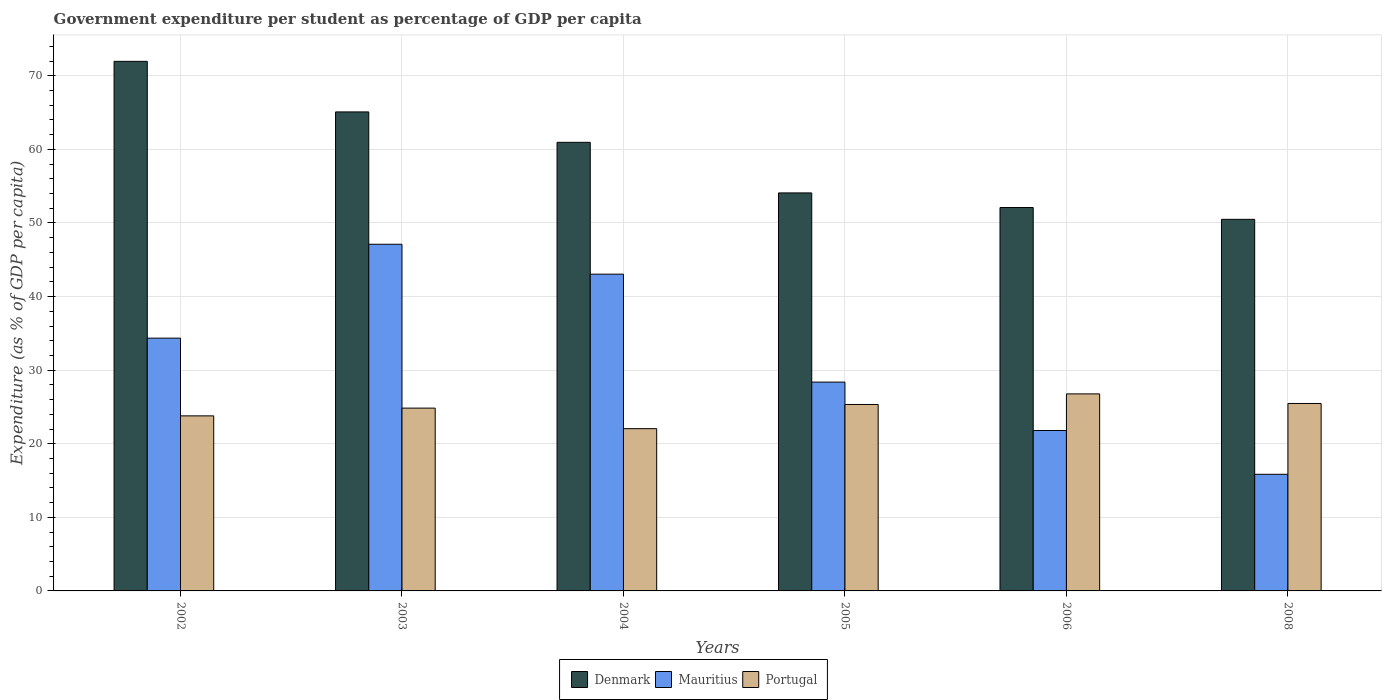How many groups of bars are there?
Offer a terse response. 6. Are the number of bars on each tick of the X-axis equal?
Ensure brevity in your answer.  Yes. In how many cases, is the number of bars for a given year not equal to the number of legend labels?
Provide a succinct answer. 0. What is the percentage of expenditure per student in Mauritius in 2005?
Your answer should be compact. 28.38. Across all years, what is the maximum percentage of expenditure per student in Mauritius?
Give a very brief answer. 47.11. Across all years, what is the minimum percentage of expenditure per student in Portugal?
Offer a terse response. 22.05. In which year was the percentage of expenditure per student in Denmark maximum?
Your answer should be very brief. 2002. In which year was the percentage of expenditure per student in Denmark minimum?
Make the answer very short. 2008. What is the total percentage of expenditure per student in Mauritius in the graph?
Offer a very short reply. 190.53. What is the difference between the percentage of expenditure per student in Denmark in 2002 and that in 2006?
Offer a very short reply. 19.86. What is the difference between the percentage of expenditure per student in Denmark in 2008 and the percentage of expenditure per student in Mauritius in 2003?
Ensure brevity in your answer.  3.39. What is the average percentage of expenditure per student in Denmark per year?
Give a very brief answer. 59.12. In the year 2008, what is the difference between the percentage of expenditure per student in Denmark and percentage of expenditure per student in Mauritius?
Keep it short and to the point. 34.65. What is the ratio of the percentage of expenditure per student in Portugal in 2003 to that in 2004?
Your response must be concise. 1.13. Is the percentage of expenditure per student in Denmark in 2003 less than that in 2004?
Provide a short and direct response. No. Is the difference between the percentage of expenditure per student in Denmark in 2003 and 2004 greater than the difference between the percentage of expenditure per student in Mauritius in 2003 and 2004?
Provide a short and direct response. Yes. What is the difference between the highest and the second highest percentage of expenditure per student in Portugal?
Give a very brief answer. 1.3. What is the difference between the highest and the lowest percentage of expenditure per student in Portugal?
Your response must be concise. 4.73. In how many years, is the percentage of expenditure per student in Denmark greater than the average percentage of expenditure per student in Denmark taken over all years?
Give a very brief answer. 3. Is the sum of the percentage of expenditure per student in Portugal in 2003 and 2008 greater than the maximum percentage of expenditure per student in Mauritius across all years?
Your answer should be compact. Yes. What does the 1st bar from the left in 2006 represents?
Offer a very short reply. Denmark. What does the 2nd bar from the right in 2005 represents?
Your answer should be compact. Mauritius. Are all the bars in the graph horizontal?
Give a very brief answer. No. How many years are there in the graph?
Provide a short and direct response. 6. Where does the legend appear in the graph?
Ensure brevity in your answer.  Bottom center. What is the title of the graph?
Provide a succinct answer. Government expenditure per student as percentage of GDP per capita. What is the label or title of the Y-axis?
Provide a short and direct response. Expenditure (as % of GDP per capita). What is the Expenditure (as % of GDP per capita) of Denmark in 2002?
Give a very brief answer. 71.97. What is the Expenditure (as % of GDP per capita) in Mauritius in 2002?
Your response must be concise. 34.35. What is the Expenditure (as % of GDP per capita) of Portugal in 2002?
Provide a succinct answer. 23.79. What is the Expenditure (as % of GDP per capita) in Denmark in 2003?
Your answer should be compact. 65.09. What is the Expenditure (as % of GDP per capita) of Mauritius in 2003?
Provide a short and direct response. 47.11. What is the Expenditure (as % of GDP per capita) in Portugal in 2003?
Offer a terse response. 24.84. What is the Expenditure (as % of GDP per capita) of Denmark in 2004?
Your answer should be very brief. 60.96. What is the Expenditure (as % of GDP per capita) in Mauritius in 2004?
Offer a very short reply. 43.05. What is the Expenditure (as % of GDP per capita) of Portugal in 2004?
Your answer should be compact. 22.05. What is the Expenditure (as % of GDP per capita) of Denmark in 2005?
Offer a terse response. 54.09. What is the Expenditure (as % of GDP per capita) in Mauritius in 2005?
Your response must be concise. 28.38. What is the Expenditure (as % of GDP per capita) of Portugal in 2005?
Provide a short and direct response. 25.34. What is the Expenditure (as % of GDP per capita) in Denmark in 2006?
Offer a very short reply. 52.1. What is the Expenditure (as % of GDP per capita) of Mauritius in 2006?
Your response must be concise. 21.8. What is the Expenditure (as % of GDP per capita) of Portugal in 2006?
Make the answer very short. 26.78. What is the Expenditure (as % of GDP per capita) of Denmark in 2008?
Your response must be concise. 50.5. What is the Expenditure (as % of GDP per capita) of Mauritius in 2008?
Your response must be concise. 15.85. What is the Expenditure (as % of GDP per capita) of Portugal in 2008?
Make the answer very short. 25.47. Across all years, what is the maximum Expenditure (as % of GDP per capita) of Denmark?
Your answer should be very brief. 71.97. Across all years, what is the maximum Expenditure (as % of GDP per capita) in Mauritius?
Your answer should be very brief. 47.11. Across all years, what is the maximum Expenditure (as % of GDP per capita) of Portugal?
Your response must be concise. 26.78. Across all years, what is the minimum Expenditure (as % of GDP per capita) of Denmark?
Your answer should be compact. 50.5. Across all years, what is the minimum Expenditure (as % of GDP per capita) of Mauritius?
Give a very brief answer. 15.85. Across all years, what is the minimum Expenditure (as % of GDP per capita) of Portugal?
Provide a succinct answer. 22.05. What is the total Expenditure (as % of GDP per capita) of Denmark in the graph?
Provide a succinct answer. 354.71. What is the total Expenditure (as % of GDP per capita) of Mauritius in the graph?
Ensure brevity in your answer.  190.53. What is the total Expenditure (as % of GDP per capita) of Portugal in the graph?
Make the answer very short. 148.27. What is the difference between the Expenditure (as % of GDP per capita) in Denmark in 2002 and that in 2003?
Your answer should be very brief. 6.87. What is the difference between the Expenditure (as % of GDP per capita) in Mauritius in 2002 and that in 2003?
Ensure brevity in your answer.  -12.76. What is the difference between the Expenditure (as % of GDP per capita) of Portugal in 2002 and that in 2003?
Provide a short and direct response. -1.05. What is the difference between the Expenditure (as % of GDP per capita) in Denmark in 2002 and that in 2004?
Your answer should be compact. 11. What is the difference between the Expenditure (as % of GDP per capita) of Mauritius in 2002 and that in 2004?
Your response must be concise. -8.7. What is the difference between the Expenditure (as % of GDP per capita) in Portugal in 2002 and that in 2004?
Make the answer very short. 1.74. What is the difference between the Expenditure (as % of GDP per capita) of Denmark in 2002 and that in 2005?
Ensure brevity in your answer.  17.88. What is the difference between the Expenditure (as % of GDP per capita) of Mauritius in 2002 and that in 2005?
Ensure brevity in your answer.  5.97. What is the difference between the Expenditure (as % of GDP per capita) of Portugal in 2002 and that in 2005?
Your answer should be very brief. -1.55. What is the difference between the Expenditure (as % of GDP per capita) of Denmark in 2002 and that in 2006?
Your answer should be compact. 19.86. What is the difference between the Expenditure (as % of GDP per capita) of Mauritius in 2002 and that in 2006?
Your answer should be very brief. 12.55. What is the difference between the Expenditure (as % of GDP per capita) in Portugal in 2002 and that in 2006?
Provide a short and direct response. -2.99. What is the difference between the Expenditure (as % of GDP per capita) in Denmark in 2002 and that in 2008?
Give a very brief answer. 21.47. What is the difference between the Expenditure (as % of GDP per capita) in Mauritius in 2002 and that in 2008?
Your answer should be very brief. 18.5. What is the difference between the Expenditure (as % of GDP per capita) of Portugal in 2002 and that in 2008?
Provide a short and direct response. -1.68. What is the difference between the Expenditure (as % of GDP per capita) of Denmark in 2003 and that in 2004?
Make the answer very short. 4.13. What is the difference between the Expenditure (as % of GDP per capita) of Mauritius in 2003 and that in 2004?
Keep it short and to the point. 4.06. What is the difference between the Expenditure (as % of GDP per capita) of Portugal in 2003 and that in 2004?
Keep it short and to the point. 2.79. What is the difference between the Expenditure (as % of GDP per capita) of Denmark in 2003 and that in 2005?
Provide a short and direct response. 11.01. What is the difference between the Expenditure (as % of GDP per capita) of Mauritius in 2003 and that in 2005?
Offer a very short reply. 18.73. What is the difference between the Expenditure (as % of GDP per capita) in Portugal in 2003 and that in 2005?
Offer a terse response. -0.49. What is the difference between the Expenditure (as % of GDP per capita) of Denmark in 2003 and that in 2006?
Give a very brief answer. 12.99. What is the difference between the Expenditure (as % of GDP per capita) of Mauritius in 2003 and that in 2006?
Your response must be concise. 25.31. What is the difference between the Expenditure (as % of GDP per capita) in Portugal in 2003 and that in 2006?
Your answer should be very brief. -1.93. What is the difference between the Expenditure (as % of GDP per capita) in Denmark in 2003 and that in 2008?
Your answer should be very brief. 14.6. What is the difference between the Expenditure (as % of GDP per capita) of Mauritius in 2003 and that in 2008?
Offer a very short reply. 31.26. What is the difference between the Expenditure (as % of GDP per capita) in Portugal in 2003 and that in 2008?
Provide a short and direct response. -0.63. What is the difference between the Expenditure (as % of GDP per capita) in Denmark in 2004 and that in 2005?
Your answer should be very brief. 6.87. What is the difference between the Expenditure (as % of GDP per capita) in Mauritius in 2004 and that in 2005?
Provide a succinct answer. 14.67. What is the difference between the Expenditure (as % of GDP per capita) in Portugal in 2004 and that in 2005?
Your response must be concise. -3.29. What is the difference between the Expenditure (as % of GDP per capita) in Denmark in 2004 and that in 2006?
Keep it short and to the point. 8.86. What is the difference between the Expenditure (as % of GDP per capita) of Mauritius in 2004 and that in 2006?
Give a very brief answer. 21.25. What is the difference between the Expenditure (as % of GDP per capita) in Portugal in 2004 and that in 2006?
Your answer should be very brief. -4.73. What is the difference between the Expenditure (as % of GDP per capita) of Denmark in 2004 and that in 2008?
Offer a very short reply. 10.46. What is the difference between the Expenditure (as % of GDP per capita) in Mauritius in 2004 and that in 2008?
Your response must be concise. 27.2. What is the difference between the Expenditure (as % of GDP per capita) in Portugal in 2004 and that in 2008?
Keep it short and to the point. -3.42. What is the difference between the Expenditure (as % of GDP per capita) in Denmark in 2005 and that in 2006?
Offer a terse response. 1.99. What is the difference between the Expenditure (as % of GDP per capita) in Mauritius in 2005 and that in 2006?
Offer a terse response. 6.58. What is the difference between the Expenditure (as % of GDP per capita) in Portugal in 2005 and that in 2006?
Your response must be concise. -1.44. What is the difference between the Expenditure (as % of GDP per capita) of Denmark in 2005 and that in 2008?
Make the answer very short. 3.59. What is the difference between the Expenditure (as % of GDP per capita) of Mauritius in 2005 and that in 2008?
Provide a short and direct response. 12.53. What is the difference between the Expenditure (as % of GDP per capita) of Portugal in 2005 and that in 2008?
Give a very brief answer. -0.14. What is the difference between the Expenditure (as % of GDP per capita) of Denmark in 2006 and that in 2008?
Your response must be concise. 1.61. What is the difference between the Expenditure (as % of GDP per capita) of Mauritius in 2006 and that in 2008?
Offer a very short reply. 5.95. What is the difference between the Expenditure (as % of GDP per capita) in Portugal in 2006 and that in 2008?
Provide a short and direct response. 1.3. What is the difference between the Expenditure (as % of GDP per capita) in Denmark in 2002 and the Expenditure (as % of GDP per capita) in Mauritius in 2003?
Offer a terse response. 24.86. What is the difference between the Expenditure (as % of GDP per capita) of Denmark in 2002 and the Expenditure (as % of GDP per capita) of Portugal in 2003?
Provide a succinct answer. 47.12. What is the difference between the Expenditure (as % of GDP per capita) of Mauritius in 2002 and the Expenditure (as % of GDP per capita) of Portugal in 2003?
Make the answer very short. 9.51. What is the difference between the Expenditure (as % of GDP per capita) of Denmark in 2002 and the Expenditure (as % of GDP per capita) of Mauritius in 2004?
Provide a succinct answer. 28.92. What is the difference between the Expenditure (as % of GDP per capita) in Denmark in 2002 and the Expenditure (as % of GDP per capita) in Portugal in 2004?
Offer a very short reply. 49.92. What is the difference between the Expenditure (as % of GDP per capita) in Mauritius in 2002 and the Expenditure (as % of GDP per capita) in Portugal in 2004?
Provide a short and direct response. 12.3. What is the difference between the Expenditure (as % of GDP per capita) in Denmark in 2002 and the Expenditure (as % of GDP per capita) in Mauritius in 2005?
Provide a succinct answer. 43.59. What is the difference between the Expenditure (as % of GDP per capita) of Denmark in 2002 and the Expenditure (as % of GDP per capita) of Portugal in 2005?
Give a very brief answer. 46.63. What is the difference between the Expenditure (as % of GDP per capita) in Mauritius in 2002 and the Expenditure (as % of GDP per capita) in Portugal in 2005?
Make the answer very short. 9.01. What is the difference between the Expenditure (as % of GDP per capita) in Denmark in 2002 and the Expenditure (as % of GDP per capita) in Mauritius in 2006?
Make the answer very short. 50.17. What is the difference between the Expenditure (as % of GDP per capita) in Denmark in 2002 and the Expenditure (as % of GDP per capita) in Portugal in 2006?
Your response must be concise. 45.19. What is the difference between the Expenditure (as % of GDP per capita) of Mauritius in 2002 and the Expenditure (as % of GDP per capita) of Portugal in 2006?
Offer a very short reply. 7.57. What is the difference between the Expenditure (as % of GDP per capita) in Denmark in 2002 and the Expenditure (as % of GDP per capita) in Mauritius in 2008?
Provide a short and direct response. 56.12. What is the difference between the Expenditure (as % of GDP per capita) of Denmark in 2002 and the Expenditure (as % of GDP per capita) of Portugal in 2008?
Provide a succinct answer. 46.49. What is the difference between the Expenditure (as % of GDP per capita) in Mauritius in 2002 and the Expenditure (as % of GDP per capita) in Portugal in 2008?
Keep it short and to the point. 8.88. What is the difference between the Expenditure (as % of GDP per capita) of Denmark in 2003 and the Expenditure (as % of GDP per capita) of Mauritius in 2004?
Your answer should be compact. 22.05. What is the difference between the Expenditure (as % of GDP per capita) of Denmark in 2003 and the Expenditure (as % of GDP per capita) of Portugal in 2004?
Keep it short and to the point. 43.04. What is the difference between the Expenditure (as % of GDP per capita) of Mauritius in 2003 and the Expenditure (as % of GDP per capita) of Portugal in 2004?
Your answer should be very brief. 25.06. What is the difference between the Expenditure (as % of GDP per capita) in Denmark in 2003 and the Expenditure (as % of GDP per capita) in Mauritius in 2005?
Your response must be concise. 36.72. What is the difference between the Expenditure (as % of GDP per capita) of Denmark in 2003 and the Expenditure (as % of GDP per capita) of Portugal in 2005?
Provide a succinct answer. 39.76. What is the difference between the Expenditure (as % of GDP per capita) in Mauritius in 2003 and the Expenditure (as % of GDP per capita) in Portugal in 2005?
Your answer should be very brief. 21.77. What is the difference between the Expenditure (as % of GDP per capita) of Denmark in 2003 and the Expenditure (as % of GDP per capita) of Mauritius in 2006?
Your answer should be very brief. 43.29. What is the difference between the Expenditure (as % of GDP per capita) in Denmark in 2003 and the Expenditure (as % of GDP per capita) in Portugal in 2006?
Offer a very short reply. 38.32. What is the difference between the Expenditure (as % of GDP per capita) of Mauritius in 2003 and the Expenditure (as % of GDP per capita) of Portugal in 2006?
Ensure brevity in your answer.  20.33. What is the difference between the Expenditure (as % of GDP per capita) in Denmark in 2003 and the Expenditure (as % of GDP per capita) in Mauritius in 2008?
Give a very brief answer. 49.24. What is the difference between the Expenditure (as % of GDP per capita) of Denmark in 2003 and the Expenditure (as % of GDP per capita) of Portugal in 2008?
Your answer should be compact. 39.62. What is the difference between the Expenditure (as % of GDP per capita) of Mauritius in 2003 and the Expenditure (as % of GDP per capita) of Portugal in 2008?
Your response must be concise. 21.64. What is the difference between the Expenditure (as % of GDP per capita) in Denmark in 2004 and the Expenditure (as % of GDP per capita) in Mauritius in 2005?
Your response must be concise. 32.58. What is the difference between the Expenditure (as % of GDP per capita) in Denmark in 2004 and the Expenditure (as % of GDP per capita) in Portugal in 2005?
Offer a very short reply. 35.62. What is the difference between the Expenditure (as % of GDP per capita) of Mauritius in 2004 and the Expenditure (as % of GDP per capita) of Portugal in 2005?
Offer a very short reply. 17.71. What is the difference between the Expenditure (as % of GDP per capita) in Denmark in 2004 and the Expenditure (as % of GDP per capita) in Mauritius in 2006?
Offer a terse response. 39.16. What is the difference between the Expenditure (as % of GDP per capita) of Denmark in 2004 and the Expenditure (as % of GDP per capita) of Portugal in 2006?
Your response must be concise. 34.19. What is the difference between the Expenditure (as % of GDP per capita) in Mauritius in 2004 and the Expenditure (as % of GDP per capita) in Portugal in 2006?
Offer a very short reply. 16.27. What is the difference between the Expenditure (as % of GDP per capita) in Denmark in 2004 and the Expenditure (as % of GDP per capita) in Mauritius in 2008?
Provide a succinct answer. 45.11. What is the difference between the Expenditure (as % of GDP per capita) in Denmark in 2004 and the Expenditure (as % of GDP per capita) in Portugal in 2008?
Offer a terse response. 35.49. What is the difference between the Expenditure (as % of GDP per capita) of Mauritius in 2004 and the Expenditure (as % of GDP per capita) of Portugal in 2008?
Offer a very short reply. 17.57. What is the difference between the Expenditure (as % of GDP per capita) of Denmark in 2005 and the Expenditure (as % of GDP per capita) of Mauritius in 2006?
Keep it short and to the point. 32.29. What is the difference between the Expenditure (as % of GDP per capita) in Denmark in 2005 and the Expenditure (as % of GDP per capita) in Portugal in 2006?
Provide a succinct answer. 27.31. What is the difference between the Expenditure (as % of GDP per capita) in Mauritius in 2005 and the Expenditure (as % of GDP per capita) in Portugal in 2006?
Your response must be concise. 1.6. What is the difference between the Expenditure (as % of GDP per capita) of Denmark in 2005 and the Expenditure (as % of GDP per capita) of Mauritius in 2008?
Provide a succinct answer. 38.24. What is the difference between the Expenditure (as % of GDP per capita) in Denmark in 2005 and the Expenditure (as % of GDP per capita) in Portugal in 2008?
Offer a terse response. 28.61. What is the difference between the Expenditure (as % of GDP per capita) in Mauritius in 2005 and the Expenditure (as % of GDP per capita) in Portugal in 2008?
Your answer should be compact. 2.91. What is the difference between the Expenditure (as % of GDP per capita) in Denmark in 2006 and the Expenditure (as % of GDP per capita) in Mauritius in 2008?
Your answer should be compact. 36.25. What is the difference between the Expenditure (as % of GDP per capita) in Denmark in 2006 and the Expenditure (as % of GDP per capita) in Portugal in 2008?
Your answer should be compact. 26.63. What is the difference between the Expenditure (as % of GDP per capita) of Mauritius in 2006 and the Expenditure (as % of GDP per capita) of Portugal in 2008?
Give a very brief answer. -3.67. What is the average Expenditure (as % of GDP per capita) in Denmark per year?
Keep it short and to the point. 59.12. What is the average Expenditure (as % of GDP per capita) in Mauritius per year?
Your response must be concise. 31.76. What is the average Expenditure (as % of GDP per capita) of Portugal per year?
Your answer should be compact. 24.71. In the year 2002, what is the difference between the Expenditure (as % of GDP per capita) in Denmark and Expenditure (as % of GDP per capita) in Mauritius?
Provide a succinct answer. 37.62. In the year 2002, what is the difference between the Expenditure (as % of GDP per capita) in Denmark and Expenditure (as % of GDP per capita) in Portugal?
Provide a short and direct response. 48.18. In the year 2002, what is the difference between the Expenditure (as % of GDP per capita) of Mauritius and Expenditure (as % of GDP per capita) of Portugal?
Provide a short and direct response. 10.56. In the year 2003, what is the difference between the Expenditure (as % of GDP per capita) of Denmark and Expenditure (as % of GDP per capita) of Mauritius?
Make the answer very short. 17.98. In the year 2003, what is the difference between the Expenditure (as % of GDP per capita) of Denmark and Expenditure (as % of GDP per capita) of Portugal?
Provide a succinct answer. 40.25. In the year 2003, what is the difference between the Expenditure (as % of GDP per capita) of Mauritius and Expenditure (as % of GDP per capita) of Portugal?
Your answer should be very brief. 22.27. In the year 2004, what is the difference between the Expenditure (as % of GDP per capita) of Denmark and Expenditure (as % of GDP per capita) of Mauritius?
Ensure brevity in your answer.  17.91. In the year 2004, what is the difference between the Expenditure (as % of GDP per capita) in Denmark and Expenditure (as % of GDP per capita) in Portugal?
Offer a very short reply. 38.91. In the year 2004, what is the difference between the Expenditure (as % of GDP per capita) of Mauritius and Expenditure (as % of GDP per capita) of Portugal?
Provide a succinct answer. 21. In the year 2005, what is the difference between the Expenditure (as % of GDP per capita) of Denmark and Expenditure (as % of GDP per capita) of Mauritius?
Your response must be concise. 25.71. In the year 2005, what is the difference between the Expenditure (as % of GDP per capita) of Denmark and Expenditure (as % of GDP per capita) of Portugal?
Ensure brevity in your answer.  28.75. In the year 2005, what is the difference between the Expenditure (as % of GDP per capita) of Mauritius and Expenditure (as % of GDP per capita) of Portugal?
Your answer should be very brief. 3.04. In the year 2006, what is the difference between the Expenditure (as % of GDP per capita) in Denmark and Expenditure (as % of GDP per capita) in Mauritius?
Offer a terse response. 30.3. In the year 2006, what is the difference between the Expenditure (as % of GDP per capita) of Denmark and Expenditure (as % of GDP per capita) of Portugal?
Your answer should be compact. 25.33. In the year 2006, what is the difference between the Expenditure (as % of GDP per capita) of Mauritius and Expenditure (as % of GDP per capita) of Portugal?
Provide a succinct answer. -4.98. In the year 2008, what is the difference between the Expenditure (as % of GDP per capita) in Denmark and Expenditure (as % of GDP per capita) in Mauritius?
Keep it short and to the point. 34.65. In the year 2008, what is the difference between the Expenditure (as % of GDP per capita) of Denmark and Expenditure (as % of GDP per capita) of Portugal?
Keep it short and to the point. 25.02. In the year 2008, what is the difference between the Expenditure (as % of GDP per capita) of Mauritius and Expenditure (as % of GDP per capita) of Portugal?
Offer a terse response. -9.62. What is the ratio of the Expenditure (as % of GDP per capita) of Denmark in 2002 to that in 2003?
Provide a succinct answer. 1.11. What is the ratio of the Expenditure (as % of GDP per capita) of Mauritius in 2002 to that in 2003?
Your answer should be compact. 0.73. What is the ratio of the Expenditure (as % of GDP per capita) in Portugal in 2002 to that in 2003?
Make the answer very short. 0.96. What is the ratio of the Expenditure (as % of GDP per capita) of Denmark in 2002 to that in 2004?
Offer a terse response. 1.18. What is the ratio of the Expenditure (as % of GDP per capita) in Mauritius in 2002 to that in 2004?
Offer a very short reply. 0.8. What is the ratio of the Expenditure (as % of GDP per capita) in Portugal in 2002 to that in 2004?
Give a very brief answer. 1.08. What is the ratio of the Expenditure (as % of GDP per capita) of Denmark in 2002 to that in 2005?
Your response must be concise. 1.33. What is the ratio of the Expenditure (as % of GDP per capita) in Mauritius in 2002 to that in 2005?
Keep it short and to the point. 1.21. What is the ratio of the Expenditure (as % of GDP per capita) of Portugal in 2002 to that in 2005?
Provide a short and direct response. 0.94. What is the ratio of the Expenditure (as % of GDP per capita) in Denmark in 2002 to that in 2006?
Your answer should be compact. 1.38. What is the ratio of the Expenditure (as % of GDP per capita) of Mauritius in 2002 to that in 2006?
Offer a terse response. 1.58. What is the ratio of the Expenditure (as % of GDP per capita) of Portugal in 2002 to that in 2006?
Provide a succinct answer. 0.89. What is the ratio of the Expenditure (as % of GDP per capita) of Denmark in 2002 to that in 2008?
Make the answer very short. 1.43. What is the ratio of the Expenditure (as % of GDP per capita) in Mauritius in 2002 to that in 2008?
Your answer should be very brief. 2.17. What is the ratio of the Expenditure (as % of GDP per capita) in Portugal in 2002 to that in 2008?
Provide a succinct answer. 0.93. What is the ratio of the Expenditure (as % of GDP per capita) in Denmark in 2003 to that in 2004?
Offer a terse response. 1.07. What is the ratio of the Expenditure (as % of GDP per capita) in Mauritius in 2003 to that in 2004?
Make the answer very short. 1.09. What is the ratio of the Expenditure (as % of GDP per capita) in Portugal in 2003 to that in 2004?
Give a very brief answer. 1.13. What is the ratio of the Expenditure (as % of GDP per capita) of Denmark in 2003 to that in 2005?
Your answer should be compact. 1.2. What is the ratio of the Expenditure (as % of GDP per capita) of Mauritius in 2003 to that in 2005?
Give a very brief answer. 1.66. What is the ratio of the Expenditure (as % of GDP per capita) in Portugal in 2003 to that in 2005?
Provide a short and direct response. 0.98. What is the ratio of the Expenditure (as % of GDP per capita) of Denmark in 2003 to that in 2006?
Make the answer very short. 1.25. What is the ratio of the Expenditure (as % of GDP per capita) in Mauritius in 2003 to that in 2006?
Provide a short and direct response. 2.16. What is the ratio of the Expenditure (as % of GDP per capita) in Portugal in 2003 to that in 2006?
Offer a very short reply. 0.93. What is the ratio of the Expenditure (as % of GDP per capita) of Denmark in 2003 to that in 2008?
Ensure brevity in your answer.  1.29. What is the ratio of the Expenditure (as % of GDP per capita) in Mauritius in 2003 to that in 2008?
Your response must be concise. 2.97. What is the ratio of the Expenditure (as % of GDP per capita) of Portugal in 2003 to that in 2008?
Make the answer very short. 0.98. What is the ratio of the Expenditure (as % of GDP per capita) of Denmark in 2004 to that in 2005?
Your answer should be compact. 1.13. What is the ratio of the Expenditure (as % of GDP per capita) of Mauritius in 2004 to that in 2005?
Keep it short and to the point. 1.52. What is the ratio of the Expenditure (as % of GDP per capita) of Portugal in 2004 to that in 2005?
Offer a very short reply. 0.87. What is the ratio of the Expenditure (as % of GDP per capita) in Denmark in 2004 to that in 2006?
Your answer should be very brief. 1.17. What is the ratio of the Expenditure (as % of GDP per capita) of Mauritius in 2004 to that in 2006?
Your answer should be compact. 1.97. What is the ratio of the Expenditure (as % of GDP per capita) in Portugal in 2004 to that in 2006?
Offer a terse response. 0.82. What is the ratio of the Expenditure (as % of GDP per capita) in Denmark in 2004 to that in 2008?
Provide a short and direct response. 1.21. What is the ratio of the Expenditure (as % of GDP per capita) of Mauritius in 2004 to that in 2008?
Offer a terse response. 2.72. What is the ratio of the Expenditure (as % of GDP per capita) of Portugal in 2004 to that in 2008?
Provide a short and direct response. 0.87. What is the ratio of the Expenditure (as % of GDP per capita) in Denmark in 2005 to that in 2006?
Offer a terse response. 1.04. What is the ratio of the Expenditure (as % of GDP per capita) in Mauritius in 2005 to that in 2006?
Your answer should be compact. 1.3. What is the ratio of the Expenditure (as % of GDP per capita) in Portugal in 2005 to that in 2006?
Provide a succinct answer. 0.95. What is the ratio of the Expenditure (as % of GDP per capita) of Denmark in 2005 to that in 2008?
Offer a very short reply. 1.07. What is the ratio of the Expenditure (as % of GDP per capita) of Mauritius in 2005 to that in 2008?
Your response must be concise. 1.79. What is the ratio of the Expenditure (as % of GDP per capita) of Denmark in 2006 to that in 2008?
Offer a terse response. 1.03. What is the ratio of the Expenditure (as % of GDP per capita) in Mauritius in 2006 to that in 2008?
Your answer should be compact. 1.38. What is the ratio of the Expenditure (as % of GDP per capita) of Portugal in 2006 to that in 2008?
Provide a succinct answer. 1.05. What is the difference between the highest and the second highest Expenditure (as % of GDP per capita) in Denmark?
Make the answer very short. 6.87. What is the difference between the highest and the second highest Expenditure (as % of GDP per capita) of Mauritius?
Provide a succinct answer. 4.06. What is the difference between the highest and the second highest Expenditure (as % of GDP per capita) of Portugal?
Your answer should be compact. 1.3. What is the difference between the highest and the lowest Expenditure (as % of GDP per capita) in Denmark?
Ensure brevity in your answer.  21.47. What is the difference between the highest and the lowest Expenditure (as % of GDP per capita) in Mauritius?
Keep it short and to the point. 31.26. What is the difference between the highest and the lowest Expenditure (as % of GDP per capita) in Portugal?
Your response must be concise. 4.73. 